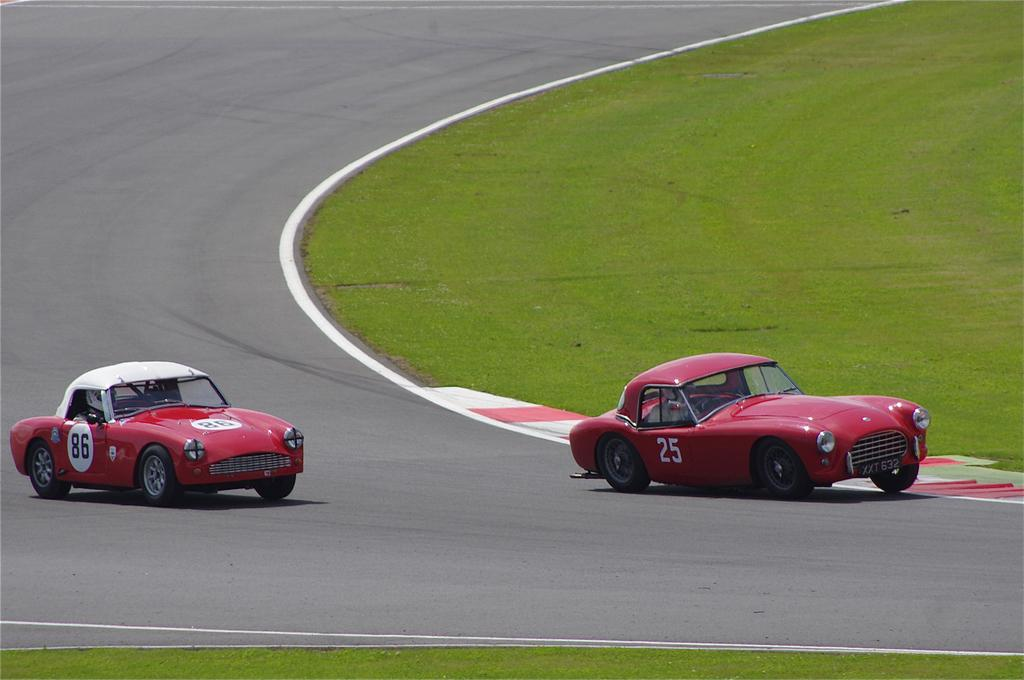How many cars are present in the image? There are two red color cars in the image. What are the cars doing in the image? The cars are racing on a runway track. What type of surface is visible on the right side of the image? There is a grass lawn on the right side of the image. Where is the son shopping for groceries in the image? There is no son or shopping activity present in the image; it features two red color cars racing on a runway track. 